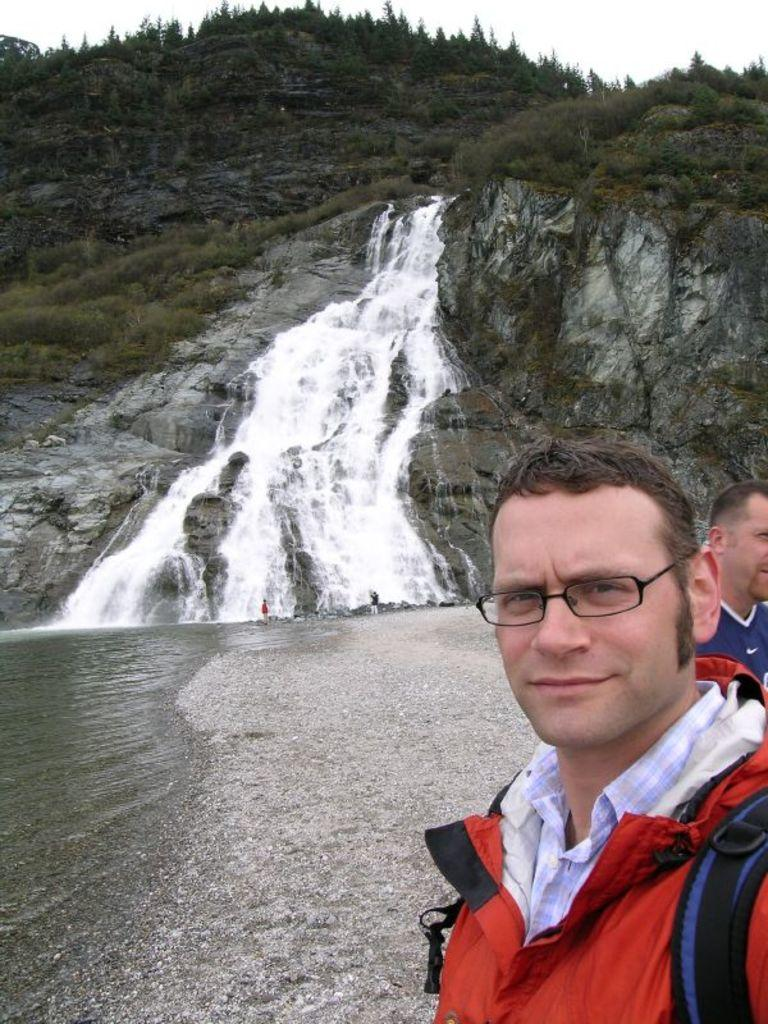How many people are present in the image? There are two persons standing in the image. What natural feature can be seen in the image? There is a waterfall visible in the image. What part of the natural environment is visible in the image? The sky is visible in the image. What type of silver doll can be seen riding on a cow in the image? There is no silver doll or cow present in the image. 